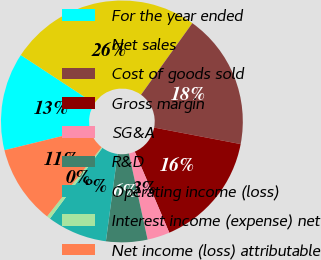Convert chart to OTSL. <chart><loc_0><loc_0><loc_500><loc_500><pie_chart><fcel>For the year ended<fcel>Net sales<fcel>Cost of goods sold<fcel>Gross margin<fcel>SG&A<fcel>R&D<fcel>Operating income (loss)<fcel>Interest income (expense) net<fcel>Net income (loss) attributable<nl><fcel>13.07%<fcel>25.65%<fcel>18.1%<fcel>15.59%<fcel>3.0%<fcel>5.52%<fcel>8.03%<fcel>0.48%<fcel>10.55%<nl></chart> 